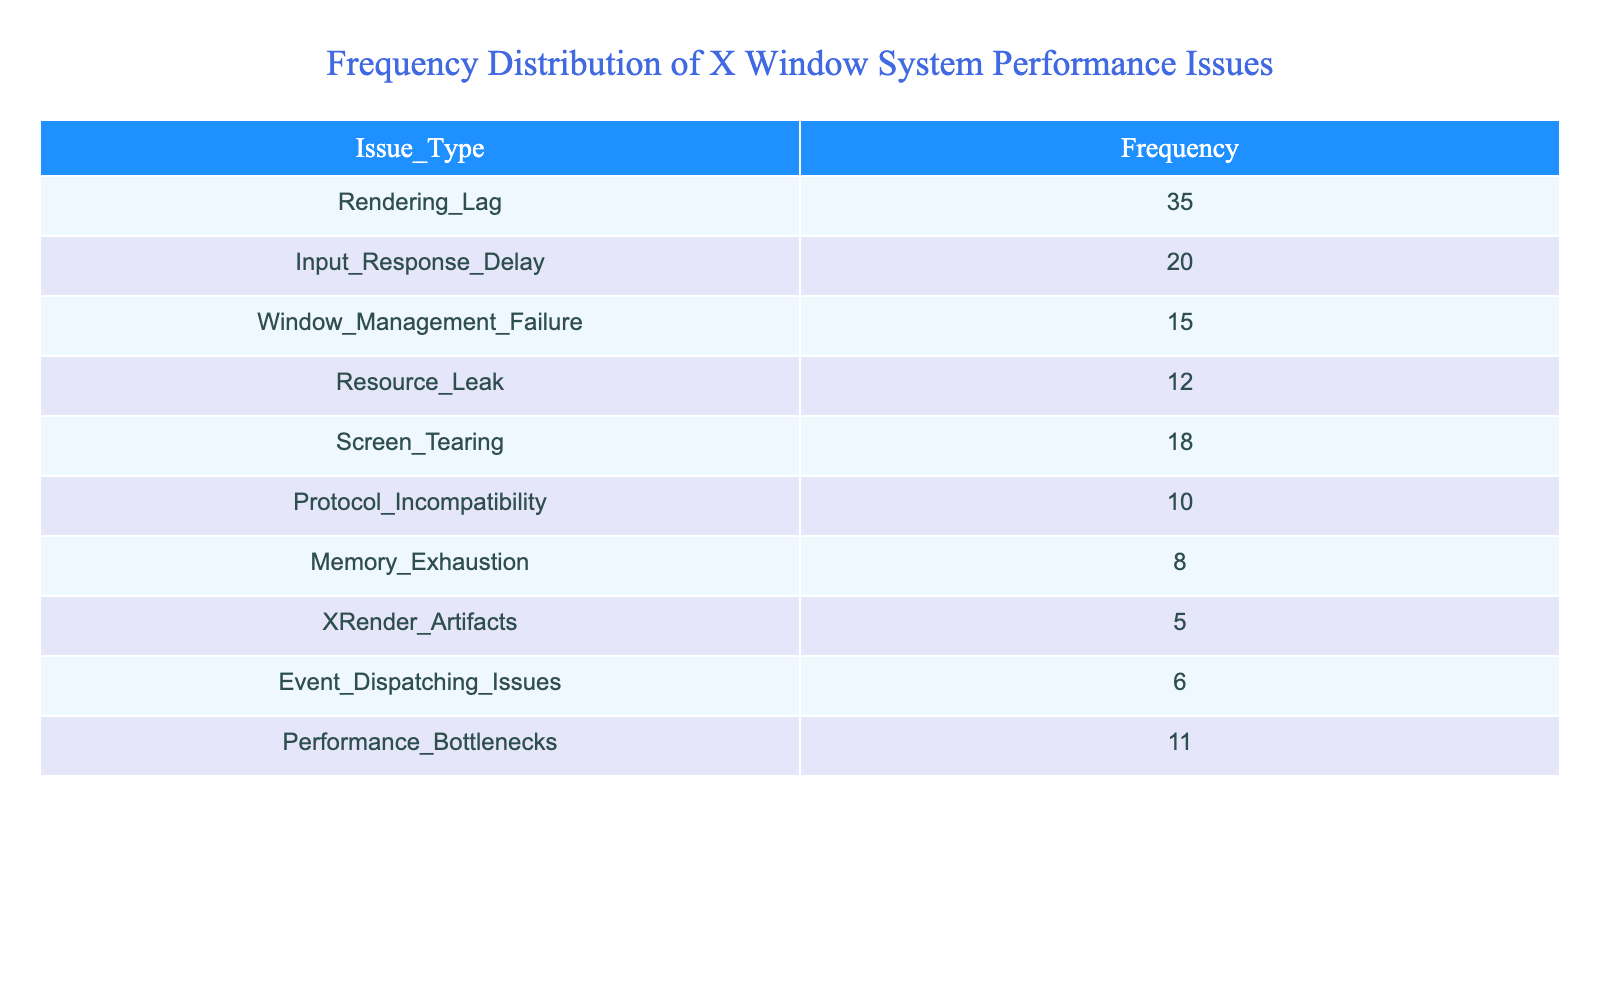What is the most frequently reported performance issue? The table lists the frequency of various performance issues. The issue with the highest frequency is Rendering Lag, with a count of 35.
Answer: Rendering Lag What is the total frequency of Input Response Delay and Resource Leak issues? From the table, Input Response Delay has a frequency of 20 and Resource Leak has a frequency of 12. Adding these gives 20 + 12 = 32.
Answer: 32 Is Screen Tearing reported more frequently than Memory Exhaustion? The frequency of Screen Tearing is 18, while Memory Exhaustion is reported at 8. Since 18 is greater than 8, the statement is true.
Answer: Yes What is the least reported issue in the table? Reviewing the table shows that XRender Artifacts has the lowest frequency with a count of 5, which is less than any other issue listed.
Answer: XRender Artifacts If we combine the frequencies of Performance Bottlenecks and Window Management Failure, what is the total? The frequency of Performance Bottlenecks is 11 and Window Management Failure is 15. Summing these gives 11 + 15 = 26.
Answer: 26 Which issue is reported twice as frequently as Memory Exhaustion? Memory Exhaustion has a frequency of 8. The only issue that meets the condition of being reported twice as frequently (8 * 2 = 16) is Screen Tearing with a frequency of 18, which does not fulfill the requirement, hence there is no issue that meets this condition.
Answer: No What percentage of the total issues reported does Rendering Lag represent? To find this, calculate the total frequency: 35 + 20 + 15 + 12 + 18 + 10 + 8 + 5 + 6 + 11 =  140. Rendering Lag is 35; thus, the percentage is (35 / 140) * 100 ≈ 25%.
Answer: 25% Is the total frequency of Window Management Failure and Performance Bottlenecks greater than that of Input Response Delay? Window Management Failure has a frequency of 15, while Performance Bottlenecks has 11; combined, they total 15 + 11 = 26. Input Response Delay has a frequency of 20. Since 26 is not greater than 20, the statement is false.
Answer: No Which performance issue has a frequency within 4 of the average frequency of all reported issues? First, calculate the total frequency: 140. Since there are 10 issues, the average is 14. Comparing each frequency, Input Response Delay (20) and Window Management Failure (15) are within the range since 20 - 14 = 6 and 15 - 14 = 1.
Answer: Yes 